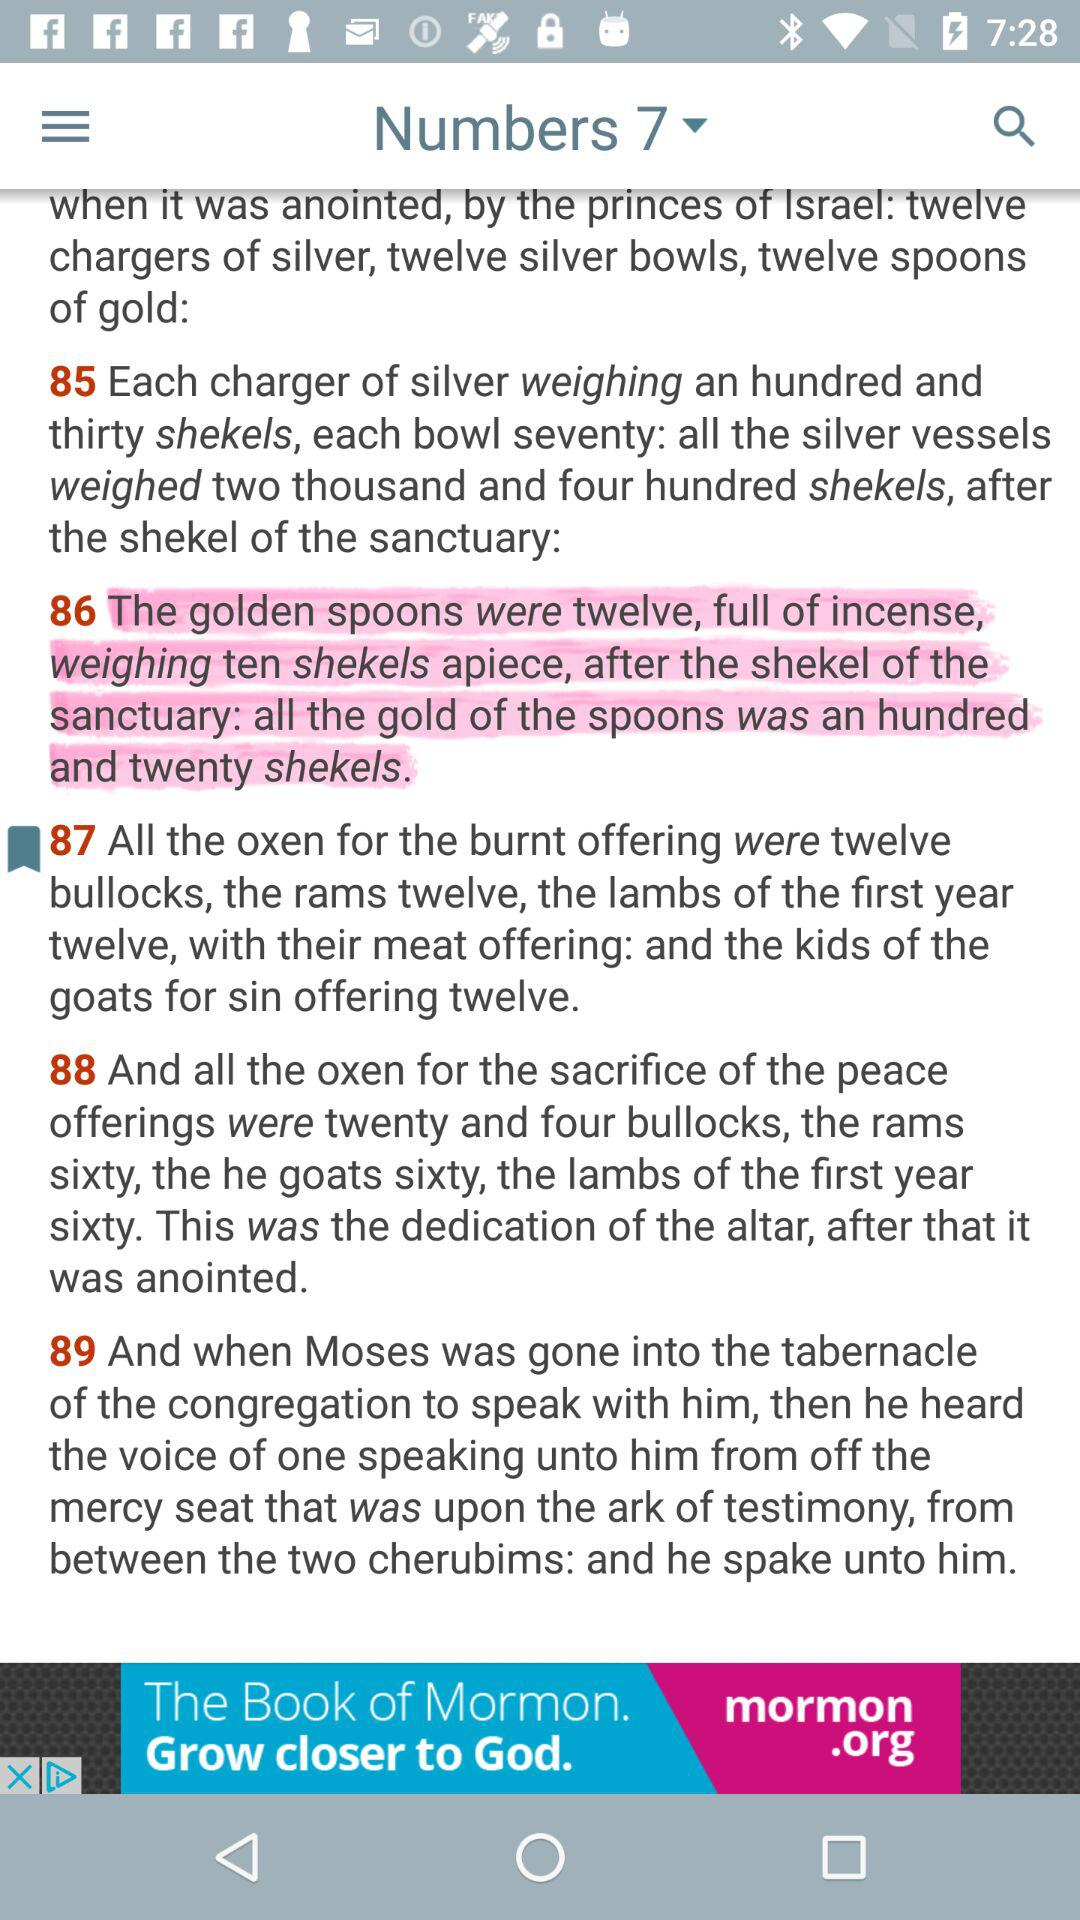How many more oxen were sacrificed for the burnt offering than for the sacrifice of the peace offerings?
Answer the question using a single word or phrase. 12 